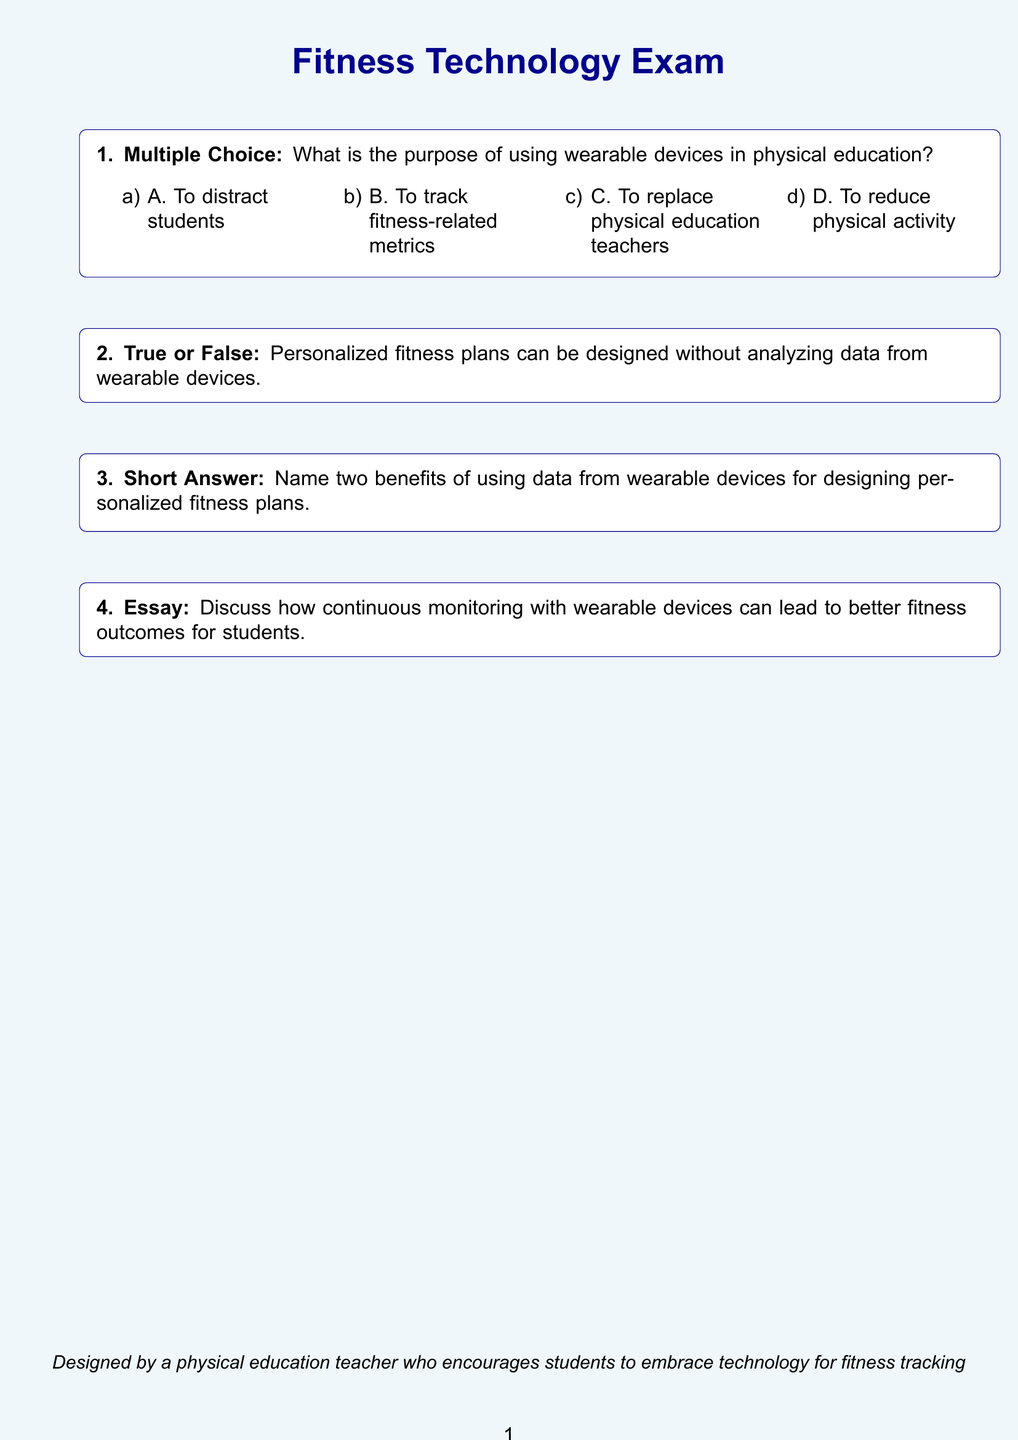What is the title of the exam? The title of the exam is formatted in a large font and highlighted within the document.
Answer: Fitness Technology Exam What color is the page background? The color of the page background is specified in the document setup using the RGB color model.
Answer: lightblue How many multiple-choice options are provided? The number of options for the multiple-choice question is indicated in the document as a part of its structure.
Answer: 4 Is the statement about personalized fitness plans true or false? The document includes a true or false statement regarding the necessity of data analysis for fitness plans.
Answer: False What is the maximum space allocated for the essay response? The document specifies the space allocated for essay responses using the command for vertical spacing.
Answer: 3cm 